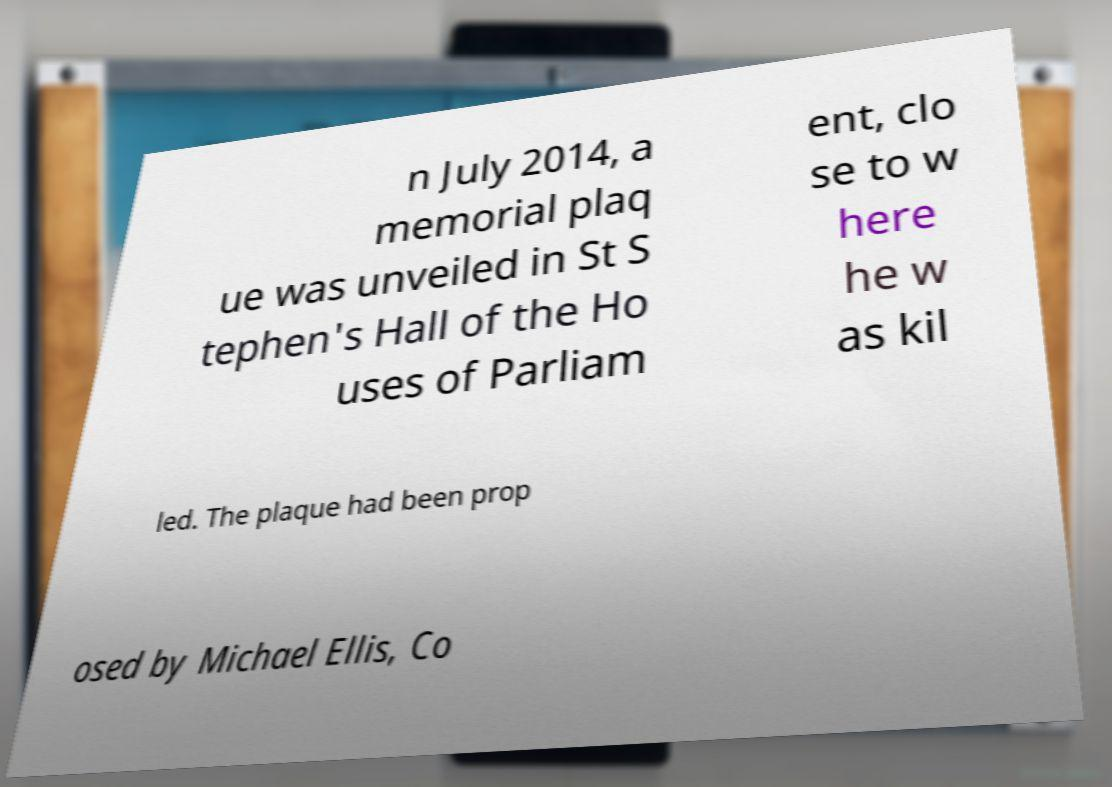Can you read and provide the text displayed in the image?This photo seems to have some interesting text. Can you extract and type it out for me? n July 2014, a memorial plaq ue was unveiled in St S tephen's Hall of the Ho uses of Parliam ent, clo se to w here he w as kil led. The plaque had been prop osed by Michael Ellis, Co 